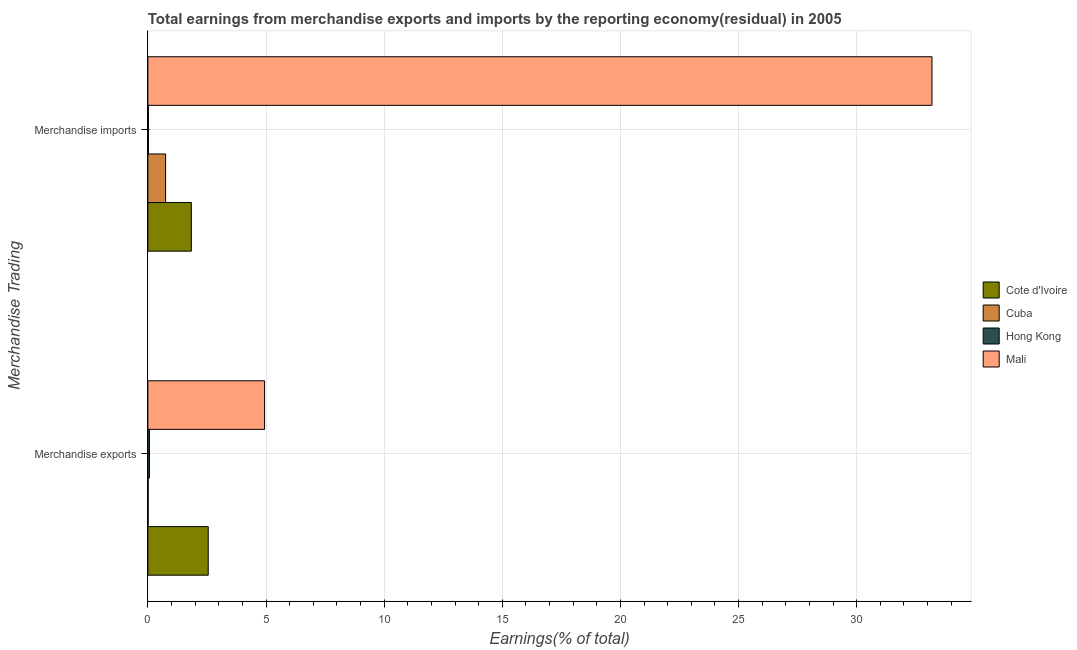How many groups of bars are there?
Ensure brevity in your answer.  2. How many bars are there on the 1st tick from the top?
Provide a succinct answer. 4. How many bars are there on the 1st tick from the bottom?
Give a very brief answer. 4. What is the label of the 2nd group of bars from the top?
Your response must be concise. Merchandise exports. What is the earnings from merchandise imports in Hong Kong?
Ensure brevity in your answer.  0.02. Across all countries, what is the maximum earnings from merchandise imports?
Keep it short and to the point. 33.19. Across all countries, what is the minimum earnings from merchandise exports?
Your response must be concise. 0.01. In which country was the earnings from merchandise imports maximum?
Keep it short and to the point. Mali. In which country was the earnings from merchandise imports minimum?
Your answer should be compact. Hong Kong. What is the total earnings from merchandise exports in the graph?
Offer a very short reply. 7.58. What is the difference between the earnings from merchandise imports in Cuba and that in Hong Kong?
Offer a terse response. 0.73. What is the difference between the earnings from merchandise imports in Cuba and the earnings from merchandise exports in Cote d'Ivoire?
Your answer should be compact. -1.8. What is the average earnings from merchandise exports per country?
Keep it short and to the point. 1.89. What is the difference between the earnings from merchandise exports and earnings from merchandise imports in Cuba?
Your response must be concise. -0.74. In how many countries, is the earnings from merchandise exports greater than 12 %?
Keep it short and to the point. 0. What is the ratio of the earnings from merchandise imports in Cote d'Ivoire to that in Mali?
Your answer should be compact. 0.06. Is the earnings from merchandise imports in Hong Kong less than that in Cuba?
Your response must be concise. Yes. In how many countries, is the earnings from merchandise imports greater than the average earnings from merchandise imports taken over all countries?
Your answer should be compact. 1. What does the 4th bar from the top in Merchandise imports represents?
Give a very brief answer. Cote d'Ivoire. What does the 1st bar from the bottom in Merchandise imports represents?
Make the answer very short. Cote d'Ivoire. Are all the bars in the graph horizontal?
Provide a short and direct response. Yes. How many countries are there in the graph?
Keep it short and to the point. 4. What is the difference between two consecutive major ticks on the X-axis?
Offer a very short reply. 5. Are the values on the major ticks of X-axis written in scientific E-notation?
Offer a very short reply. No. Where does the legend appear in the graph?
Your answer should be very brief. Center right. How many legend labels are there?
Provide a succinct answer. 4. What is the title of the graph?
Make the answer very short. Total earnings from merchandise exports and imports by the reporting economy(residual) in 2005. Does "Turkey" appear as one of the legend labels in the graph?
Ensure brevity in your answer.  No. What is the label or title of the X-axis?
Provide a succinct answer. Earnings(% of total). What is the label or title of the Y-axis?
Offer a very short reply. Merchandise Trading. What is the Earnings(% of total) in Cote d'Ivoire in Merchandise exports?
Ensure brevity in your answer.  2.56. What is the Earnings(% of total) of Cuba in Merchandise exports?
Keep it short and to the point. 0.01. What is the Earnings(% of total) in Hong Kong in Merchandise exports?
Ensure brevity in your answer.  0.07. What is the Earnings(% of total) of Mali in Merchandise exports?
Provide a succinct answer. 4.94. What is the Earnings(% of total) of Cote d'Ivoire in Merchandise imports?
Provide a succinct answer. 1.84. What is the Earnings(% of total) of Cuba in Merchandise imports?
Provide a succinct answer. 0.75. What is the Earnings(% of total) of Hong Kong in Merchandise imports?
Provide a succinct answer. 0.02. What is the Earnings(% of total) in Mali in Merchandise imports?
Offer a very short reply. 33.19. Across all Merchandise Trading, what is the maximum Earnings(% of total) in Cote d'Ivoire?
Your answer should be compact. 2.56. Across all Merchandise Trading, what is the maximum Earnings(% of total) in Cuba?
Offer a terse response. 0.75. Across all Merchandise Trading, what is the maximum Earnings(% of total) of Hong Kong?
Provide a short and direct response. 0.07. Across all Merchandise Trading, what is the maximum Earnings(% of total) of Mali?
Your answer should be very brief. 33.19. Across all Merchandise Trading, what is the minimum Earnings(% of total) in Cote d'Ivoire?
Your answer should be compact. 1.84. Across all Merchandise Trading, what is the minimum Earnings(% of total) in Cuba?
Your answer should be very brief. 0.01. Across all Merchandise Trading, what is the minimum Earnings(% of total) in Hong Kong?
Provide a short and direct response. 0.02. Across all Merchandise Trading, what is the minimum Earnings(% of total) of Mali?
Give a very brief answer. 4.94. What is the total Earnings(% of total) of Cote d'Ivoire in the graph?
Give a very brief answer. 4.4. What is the total Earnings(% of total) of Cuba in the graph?
Provide a short and direct response. 0.76. What is the total Earnings(% of total) of Hong Kong in the graph?
Provide a short and direct response. 0.09. What is the total Earnings(% of total) of Mali in the graph?
Your response must be concise. 38.13. What is the difference between the Earnings(% of total) in Cuba in Merchandise exports and that in Merchandise imports?
Give a very brief answer. -0.74. What is the difference between the Earnings(% of total) in Hong Kong in Merchandise exports and that in Merchandise imports?
Offer a terse response. 0.05. What is the difference between the Earnings(% of total) of Mali in Merchandise exports and that in Merchandise imports?
Provide a succinct answer. -28.25. What is the difference between the Earnings(% of total) in Cote d'Ivoire in Merchandise exports and the Earnings(% of total) in Cuba in Merchandise imports?
Your answer should be very brief. 1.8. What is the difference between the Earnings(% of total) of Cote d'Ivoire in Merchandise exports and the Earnings(% of total) of Hong Kong in Merchandise imports?
Offer a very short reply. 2.53. What is the difference between the Earnings(% of total) in Cote d'Ivoire in Merchandise exports and the Earnings(% of total) in Mali in Merchandise imports?
Provide a short and direct response. -30.63. What is the difference between the Earnings(% of total) in Cuba in Merchandise exports and the Earnings(% of total) in Hong Kong in Merchandise imports?
Offer a terse response. -0.01. What is the difference between the Earnings(% of total) of Cuba in Merchandise exports and the Earnings(% of total) of Mali in Merchandise imports?
Give a very brief answer. -33.18. What is the difference between the Earnings(% of total) in Hong Kong in Merchandise exports and the Earnings(% of total) in Mali in Merchandise imports?
Keep it short and to the point. -33.12. What is the average Earnings(% of total) of Cote d'Ivoire per Merchandise Trading?
Ensure brevity in your answer.  2.2. What is the average Earnings(% of total) of Cuba per Merchandise Trading?
Give a very brief answer. 0.38. What is the average Earnings(% of total) in Hong Kong per Merchandise Trading?
Offer a terse response. 0.04. What is the average Earnings(% of total) of Mali per Merchandise Trading?
Give a very brief answer. 19.06. What is the difference between the Earnings(% of total) in Cote d'Ivoire and Earnings(% of total) in Cuba in Merchandise exports?
Keep it short and to the point. 2.54. What is the difference between the Earnings(% of total) of Cote d'Ivoire and Earnings(% of total) of Hong Kong in Merchandise exports?
Give a very brief answer. 2.49. What is the difference between the Earnings(% of total) of Cote d'Ivoire and Earnings(% of total) of Mali in Merchandise exports?
Give a very brief answer. -2.38. What is the difference between the Earnings(% of total) in Cuba and Earnings(% of total) in Hong Kong in Merchandise exports?
Keep it short and to the point. -0.05. What is the difference between the Earnings(% of total) of Cuba and Earnings(% of total) of Mali in Merchandise exports?
Give a very brief answer. -4.93. What is the difference between the Earnings(% of total) of Hong Kong and Earnings(% of total) of Mali in Merchandise exports?
Provide a succinct answer. -4.87. What is the difference between the Earnings(% of total) of Cote d'Ivoire and Earnings(% of total) of Cuba in Merchandise imports?
Offer a terse response. 1.09. What is the difference between the Earnings(% of total) of Cote d'Ivoire and Earnings(% of total) of Hong Kong in Merchandise imports?
Your response must be concise. 1.82. What is the difference between the Earnings(% of total) in Cote d'Ivoire and Earnings(% of total) in Mali in Merchandise imports?
Provide a succinct answer. -31.35. What is the difference between the Earnings(% of total) in Cuba and Earnings(% of total) in Hong Kong in Merchandise imports?
Ensure brevity in your answer.  0.73. What is the difference between the Earnings(% of total) in Cuba and Earnings(% of total) in Mali in Merchandise imports?
Offer a very short reply. -32.44. What is the difference between the Earnings(% of total) of Hong Kong and Earnings(% of total) of Mali in Merchandise imports?
Make the answer very short. -33.17. What is the ratio of the Earnings(% of total) of Cote d'Ivoire in Merchandise exports to that in Merchandise imports?
Ensure brevity in your answer.  1.39. What is the ratio of the Earnings(% of total) of Cuba in Merchandise exports to that in Merchandise imports?
Your answer should be compact. 0.02. What is the ratio of the Earnings(% of total) in Hong Kong in Merchandise exports to that in Merchandise imports?
Keep it short and to the point. 3.06. What is the ratio of the Earnings(% of total) of Mali in Merchandise exports to that in Merchandise imports?
Make the answer very short. 0.15. What is the difference between the highest and the second highest Earnings(% of total) in Cuba?
Your response must be concise. 0.74. What is the difference between the highest and the second highest Earnings(% of total) of Hong Kong?
Offer a very short reply. 0.05. What is the difference between the highest and the second highest Earnings(% of total) in Mali?
Provide a short and direct response. 28.25. What is the difference between the highest and the lowest Earnings(% of total) in Cuba?
Offer a terse response. 0.74. What is the difference between the highest and the lowest Earnings(% of total) in Hong Kong?
Provide a short and direct response. 0.05. What is the difference between the highest and the lowest Earnings(% of total) of Mali?
Your answer should be compact. 28.25. 